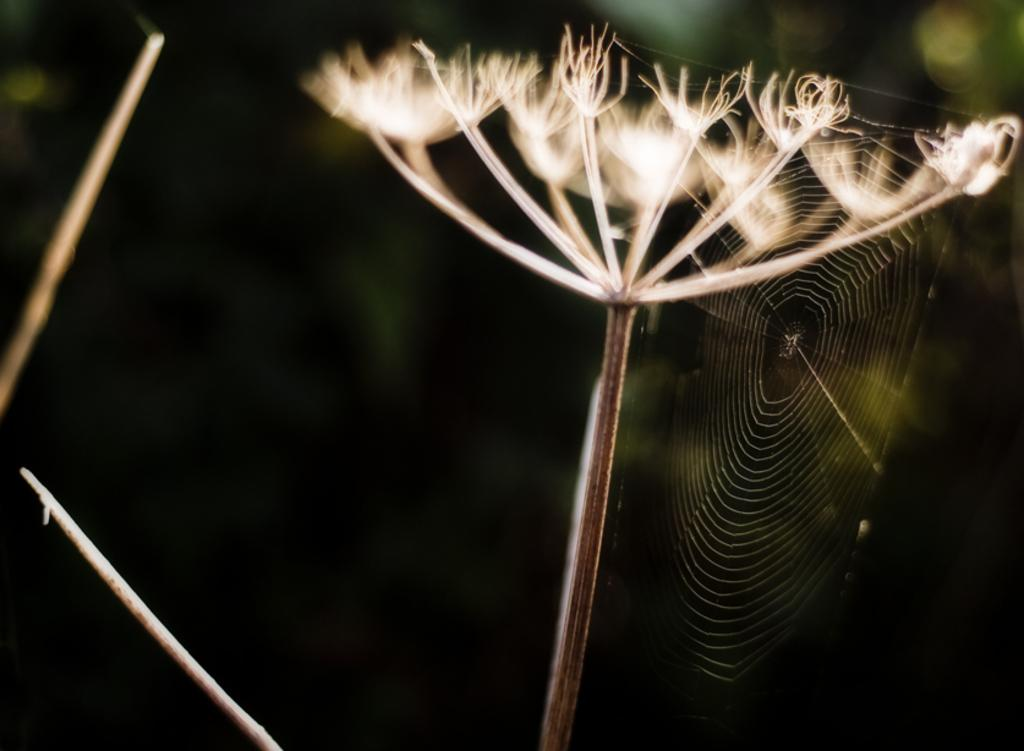What is present in the image that resembles a dandelion? There are pappus in the image, which resemble the fluffy seed heads of dandelions. What type of structure can be seen in the image? There is a spider web in the image. How would you describe the overall appearance of the image? The background of the image is blurred. What type of scarecrow is standing in the middle of the field in the image? There is no scarecrow present in the image; it only features pappus and a spider web. How many leaves can be seen on the ground in the image? There are no leaves visible in the image. 